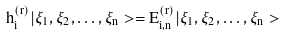Convert formula to latex. <formula><loc_0><loc_0><loc_500><loc_500>h _ { i } ^ { ( r ) } | \xi _ { 1 } , \xi _ { 2 } , \dots , \xi _ { n } > = E ^ { ( r ) } _ { i , n } | \xi _ { 1 } , \xi _ { 2 } , \dots , \xi _ { n } ></formula> 